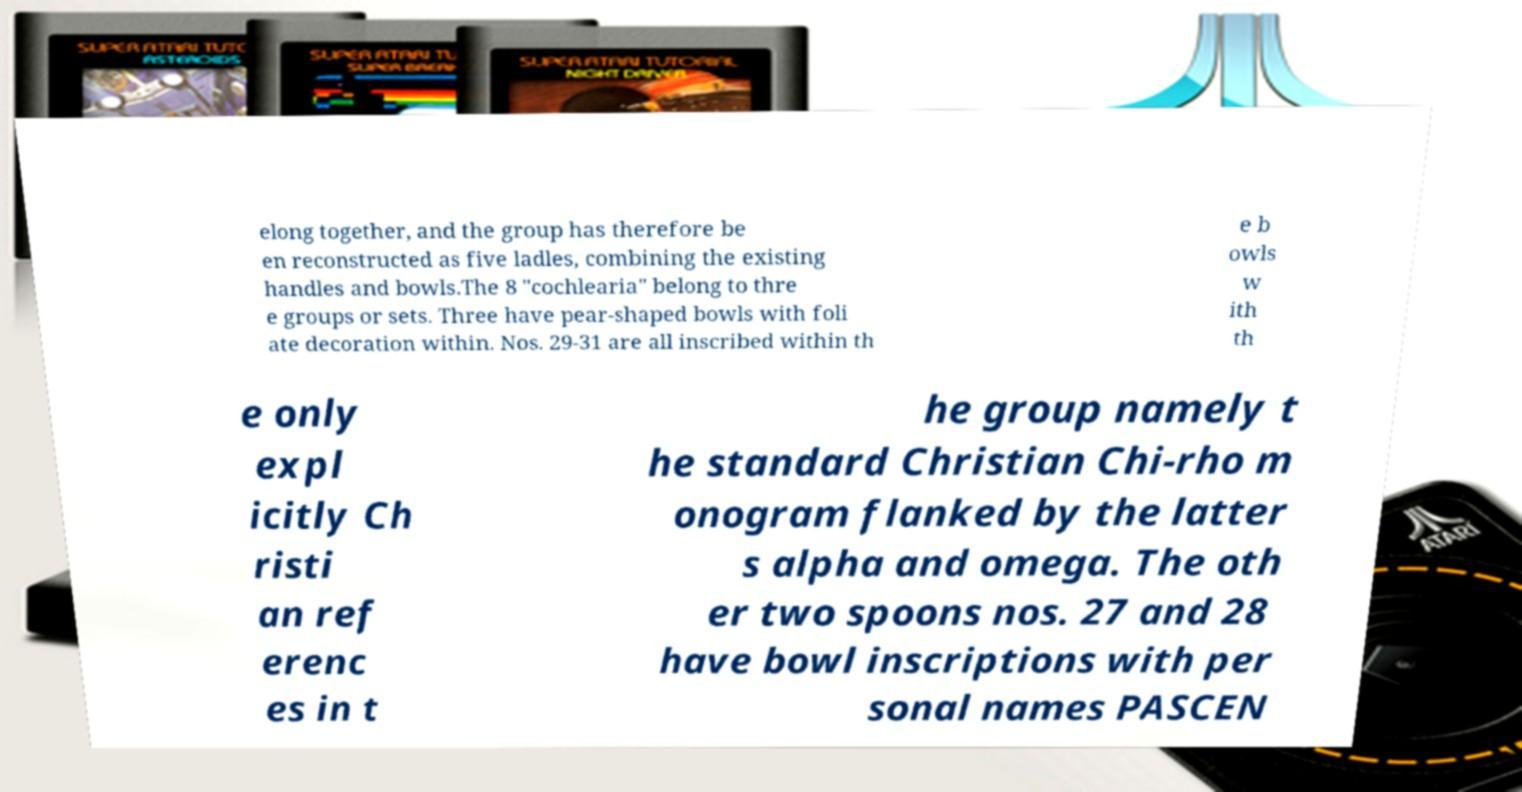Could you extract and type out the text from this image? elong together, and the group has therefore be en reconstructed as five ladles, combining the existing handles and bowls.The 8 "cochlearia" belong to thre e groups or sets. Three have pear-shaped bowls with foli ate decoration within. Nos. 29-31 are all inscribed within th e b owls w ith th e only expl icitly Ch risti an ref erenc es in t he group namely t he standard Christian Chi-rho m onogram flanked by the latter s alpha and omega. The oth er two spoons nos. 27 and 28 have bowl inscriptions with per sonal names PASCEN 